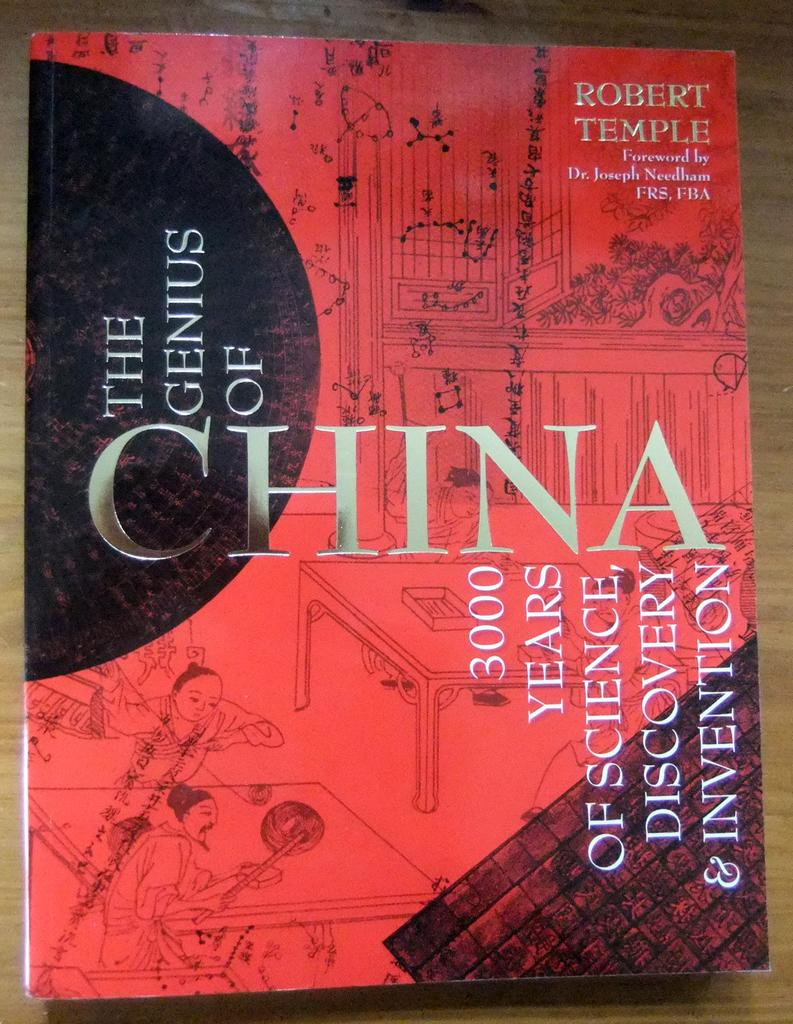<image>
Relay a brief, clear account of the picture shown. Robert Temple has authored a book about the genius of China. 